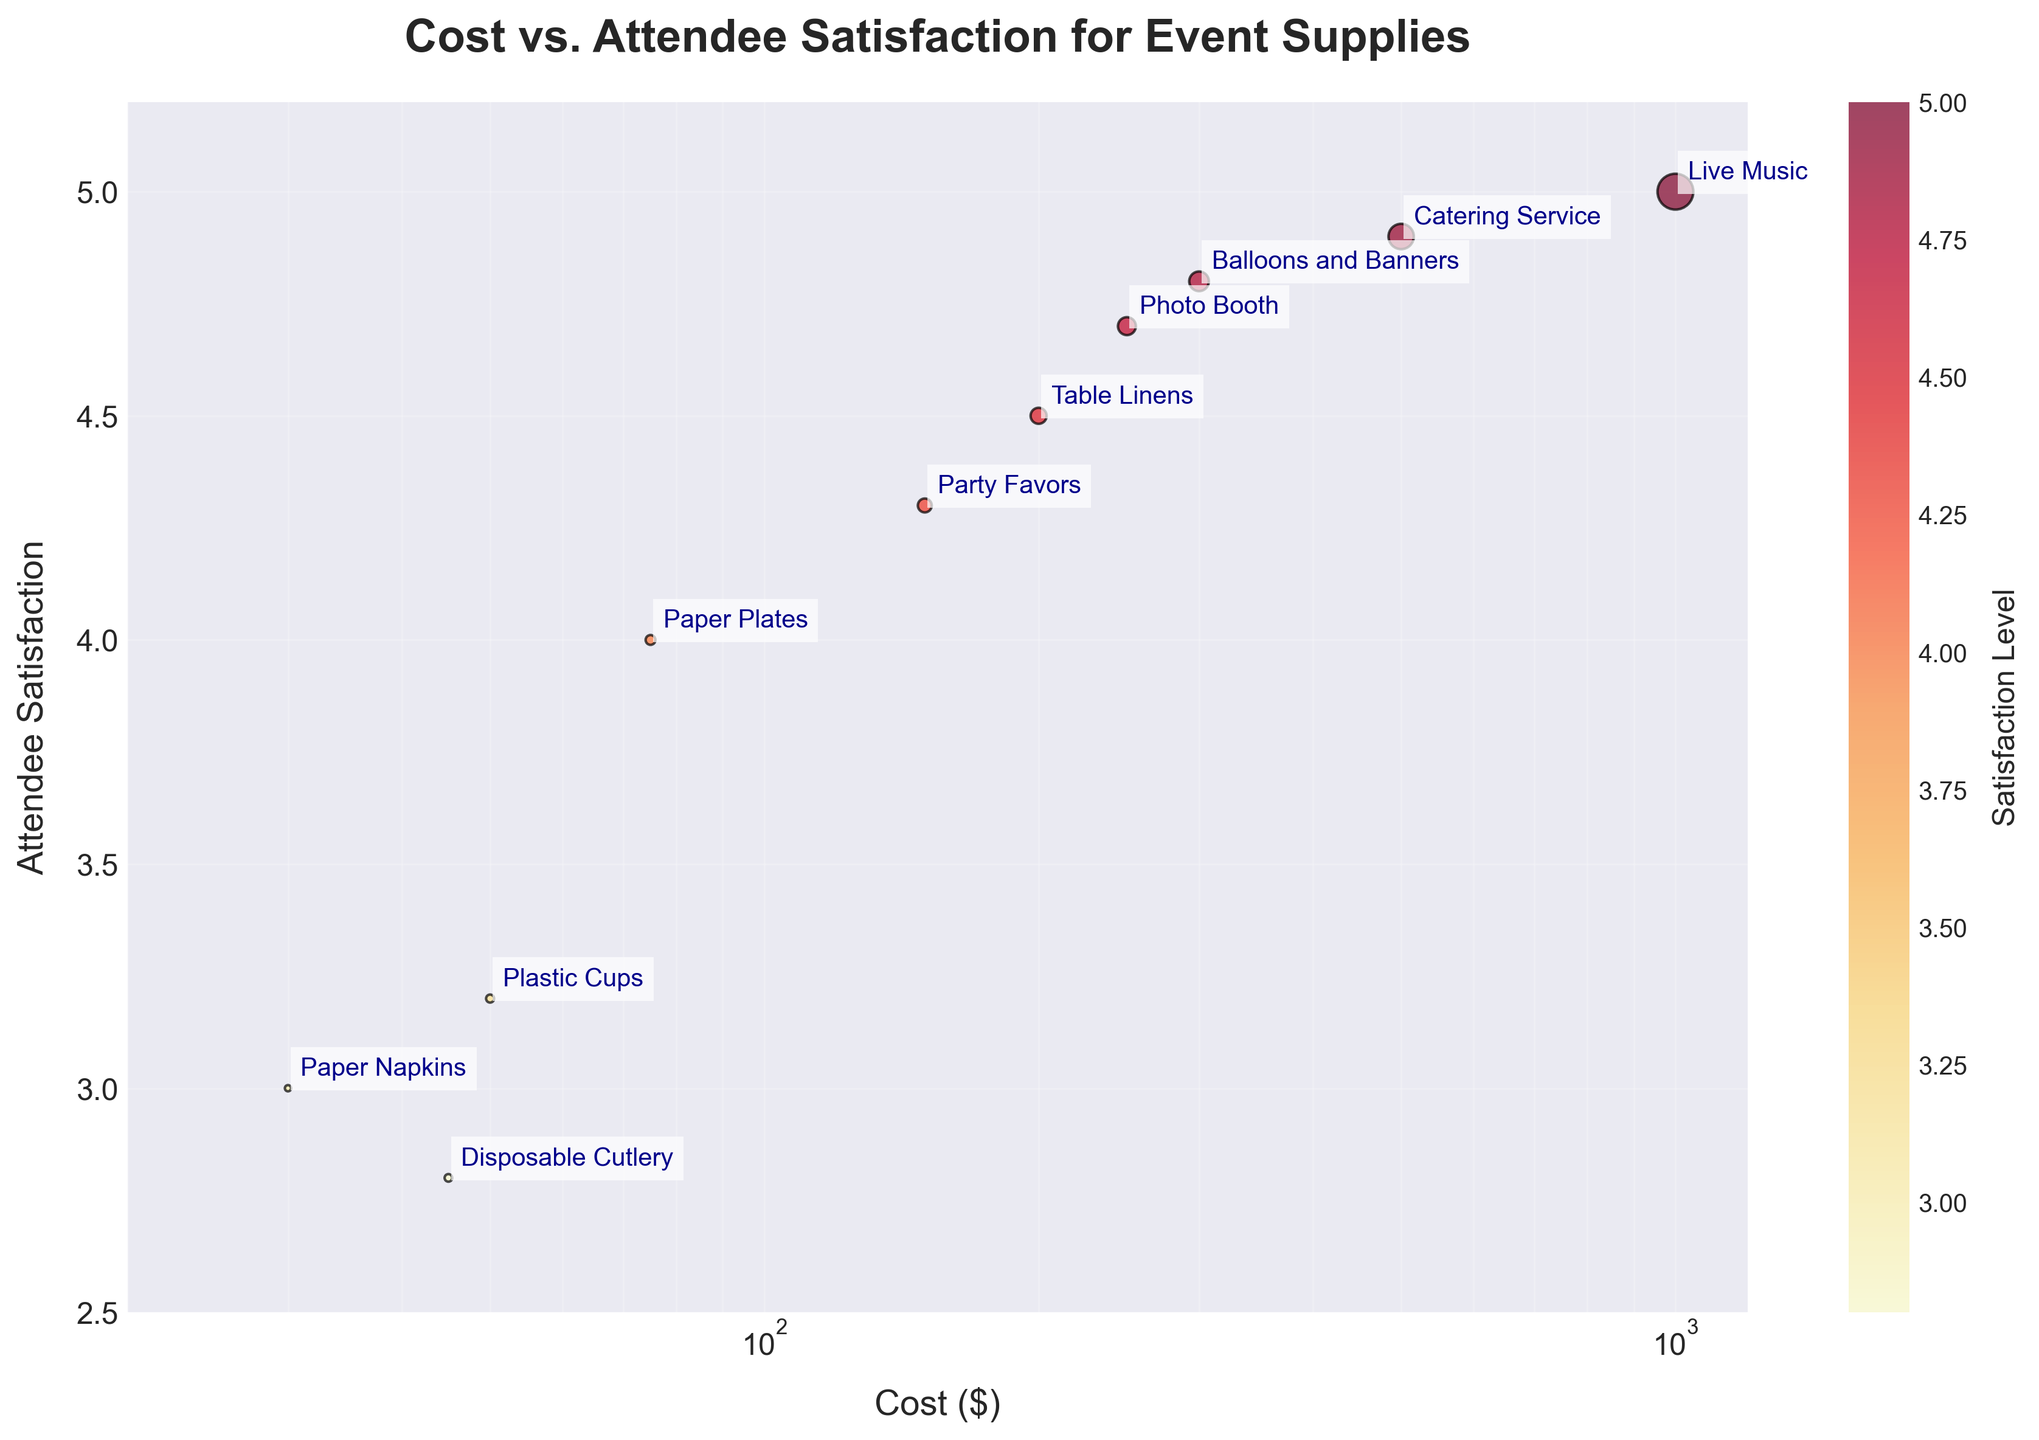What is the title of the figure? The title of the figure is displayed at the top of the plot. It is: "Cost vs. Attendee Satisfaction for Event Supplies."
Answer: Cost vs. Attendee Satisfaction for Event Supplies What is the lowest cost item on the plot? The lowest cost can be determined by looking at the x-axis and identifying the leftmost point. The item with the lowest cost is "Paper Napkins" costing $30.
Answer: Paper Napkins How many items have a satisfaction level above 4.0? Count the number of points that have a y-value (satisfaction level) greater than 4.0. There are 6 items with a satisfaction level above 4.0.
Answer: 6 Which item has the highest satisfaction level? The highest satisfaction level can be found by looking for the highest y-value on the plot. The item with the highest satisfaction level of 5.0 is "Live Music."
Answer: Live Music What is the color of the lowest satisfaction level item? The lowest satisfaction level item has the lowest y-value and is "Disposable Cutlery" with a satisfaction of 2.8. The scheme appears to correlate satisfaction levels with colors, where lower levels are more yellow.
Answer: Yellow Which item has the largest marker size? Marker size is proportional to the cost divided by 5, making "Live Music" with a $1000 cost the item with the largest marker.
Answer: Live Music What's the average cost of items with satisfaction levels of 4.5 or higher? Identify items with satisfaction levels of 4.5 or higher (Table Linens, Balloons and Banners, Catering Service, Live Music, Photo Booth). Their costs are $200, $300, $500, $1000, and $250. The average cost is (200 + 300 + 500 + 1000 + 250) / 5 = $450.
Answer: $450 Is there a positive correlation between cost and satisfaction? By observing the overall trend of the scatter plot, most higher cost items are associated with higher satisfaction levels, indicating a positive correlation.
Answer: Yes Which items cost less than $100 but have a satisfaction level above 3.0? Locate points with costs less than $100 on the x-axis and satisfaction levels above 3.0 on the y-axis. The items are "Plastic Cups" and "Paper Plates."
Answer: Plastic Cups, Paper Plates Among "Table Linens" and "Catering Service", which has a higher satisfaction level? Compare the y-values of "Table Linens" (4.5) and "Catering Service" (4.9). "Catering Service" has a higher satisfaction level.
Answer: Catering Service 